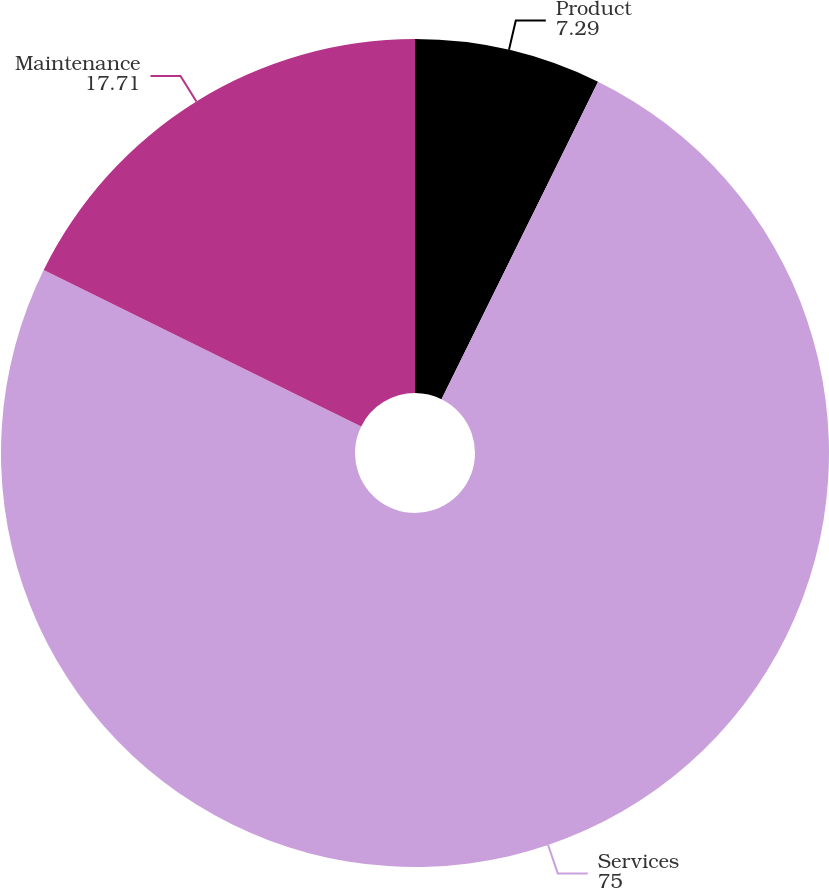Convert chart. <chart><loc_0><loc_0><loc_500><loc_500><pie_chart><fcel>Product<fcel>Services<fcel>Maintenance<nl><fcel>7.29%<fcel>75.0%<fcel>17.71%<nl></chart> 